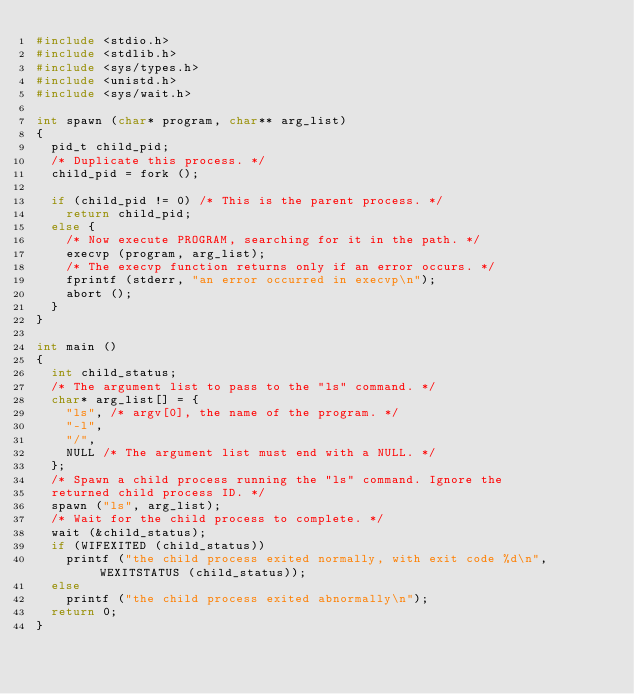<code> <loc_0><loc_0><loc_500><loc_500><_C_>#include <stdio.h>
#include <stdlib.h>
#include <sys/types.h>
#include <unistd.h>
#include <sys/wait.h>

int spawn (char* program, char** arg_list)
{
	pid_t child_pid;
	/* Duplicate this process. */
	child_pid = fork ();
	
	if (child_pid != 0) /* This is the parent process. */
		return child_pid;
	else {
		/* Now execute PROGRAM, searching for it in the path. */
		execvp (program, arg_list);
		/* The execvp function returns only if an error occurs. */
		fprintf (stderr, "an error occurred in execvp\n");
		abort ();
	}
}

int main ()
{
	int child_status;
	/* The argument list to pass to the "ls" command. */
	char* arg_list[] = {
		"ls", /* argv[0], the name of the program. */
		"-l",
		"/",
		NULL /* The argument list must end with a NULL. */
	};
	/* Spawn a child process running the "ls" command. Ignore the
	returned child process ID. */
	spawn ("ls", arg_list);
	/* Wait for the child process to complete. */
	wait (&child_status);
	if (WIFEXITED (child_status))
		printf ("the child process exited normally, with exit code %d\n", WEXITSTATUS (child_status));
	else
		printf ("the child process exited abnormally\n");
	return 0;
}

</code> 